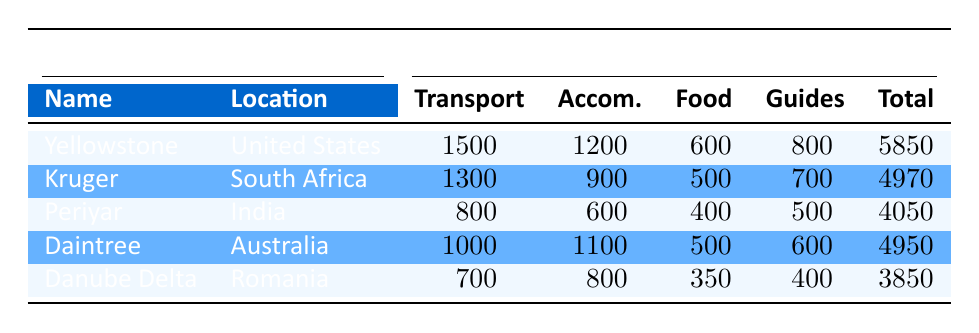What is the total monthly cost for fieldwork and equipment at Yellowstone National Park? The table provides the total monthly cost for Yellowstone National Park listed in the Total column. It specifically states that the Total Monthly Cost is 5850 USD.
Answer: 5850 What are the accommodation costs at Kruger National Park? The accommodation costs for Kruger National Park are listed directly in the table under the Accommodation column. It shows an expense of 900 USD.
Answer: 900 Which reserve has the highest transportation costs? To determine this, we need to compare the Transportation costs across all reserves. Yellowstone has 1500 USD, Kruger has 1300 USD, Periyar has 800 USD, Daintree has 1000 USD, and Danube Delta has 700 USD. The highest value is 1500 USD from Yellowstone National Park.
Answer: Yellowstone National Park What is the average total monthly cost across all reserves? We sum the Total Monthly Costs: 5850 + 4970 + 4050 + 4950 + 3850 = 23670 USD. Then we divide by the number of reserves (5): 23670 / 5 = 4734.
Answer: 4734 Is the total cost at Periyar Wildlife Sanctuary less than 4000 USD? The Total Monthly Cost for Periyar Wildlife Sanctuary is 4050 USD, which is greater than 4000 USD. Therefore, the statement is false.
Answer: No What is the difference in total monthly costs between the highest and lowest reserves? From the table, the highest Total Monthly Cost is 5850 USD (Yellowstone) and the lowest is 3850 USD (Danube Delta). The difference is calculated as 5850 - 3850 = 2000 USD.
Answer: 2000 Which reserve has the lowest expenditure on food supplies? By comparing the Food Supplies costs from the table: Yellowstone has 600, Kruger has 500, Periyar has 400, Daintree has 500, and Danube Delta has 350. The lowest expenditure is 350 USD at Danube Delta.
Answer: Danube Delta Do all reserves have costs for local guides that are equal to or above 400 USD? Reviewing the Local Guides costs: Yellowstone has 800 USD, Kruger has 700 USD, Periyar has 500 USD, Daintree has 600 USD, and Danube Delta has 400 USD. Only Danube Delta exactly meets the 400 USD threshold, so the statement is false.
Answer: No What is the total cost for food supplies across all reserves? The Food Supplies costs are: 600 (Yellowstone) + 500 (Kruger) + 400 (Periyar) + 500 (Daintree) + 350 (Danube Delta) = 2350 USD. Thus, the total cost for food supplies across all reserves is 2350 USD.
Answer: 2350 